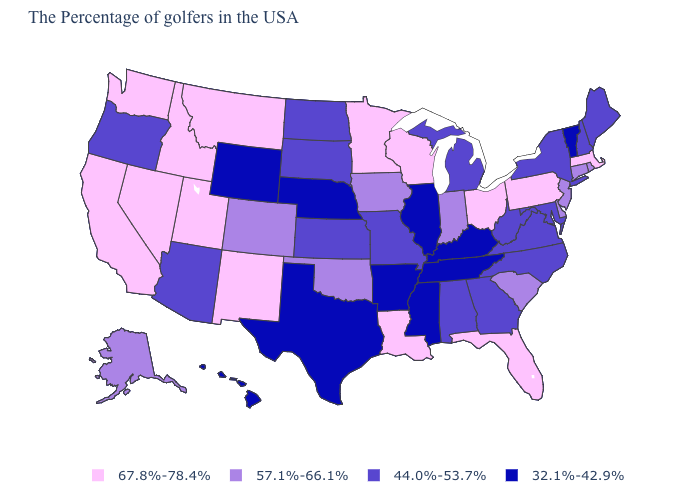Among the states that border Kansas , which have the highest value?
Answer briefly. Oklahoma, Colorado. Which states have the highest value in the USA?
Answer briefly. Massachusetts, Pennsylvania, Ohio, Florida, Wisconsin, Louisiana, Minnesota, New Mexico, Utah, Montana, Idaho, Nevada, California, Washington. Among the states that border Pennsylvania , which have the highest value?
Write a very short answer. Ohio. What is the value of Tennessee?
Concise answer only. 32.1%-42.9%. Does Illinois have the lowest value in the MidWest?
Keep it brief. Yes. What is the lowest value in the West?
Quick response, please. 32.1%-42.9%. Name the states that have a value in the range 32.1%-42.9%?
Short answer required. Vermont, Kentucky, Tennessee, Illinois, Mississippi, Arkansas, Nebraska, Texas, Wyoming, Hawaii. Which states have the highest value in the USA?
Concise answer only. Massachusetts, Pennsylvania, Ohio, Florida, Wisconsin, Louisiana, Minnesota, New Mexico, Utah, Montana, Idaho, Nevada, California, Washington. Name the states that have a value in the range 32.1%-42.9%?
Give a very brief answer. Vermont, Kentucky, Tennessee, Illinois, Mississippi, Arkansas, Nebraska, Texas, Wyoming, Hawaii. Which states have the highest value in the USA?
Keep it brief. Massachusetts, Pennsylvania, Ohio, Florida, Wisconsin, Louisiana, Minnesota, New Mexico, Utah, Montana, Idaho, Nevada, California, Washington. Does the map have missing data?
Keep it brief. No. Among the states that border North Dakota , does South Dakota have the highest value?
Be succinct. No. What is the lowest value in states that border Minnesota?
Concise answer only. 44.0%-53.7%. Among the states that border Connecticut , which have the lowest value?
Keep it brief. New York. Does Hawaii have the lowest value in the West?
Give a very brief answer. Yes. 